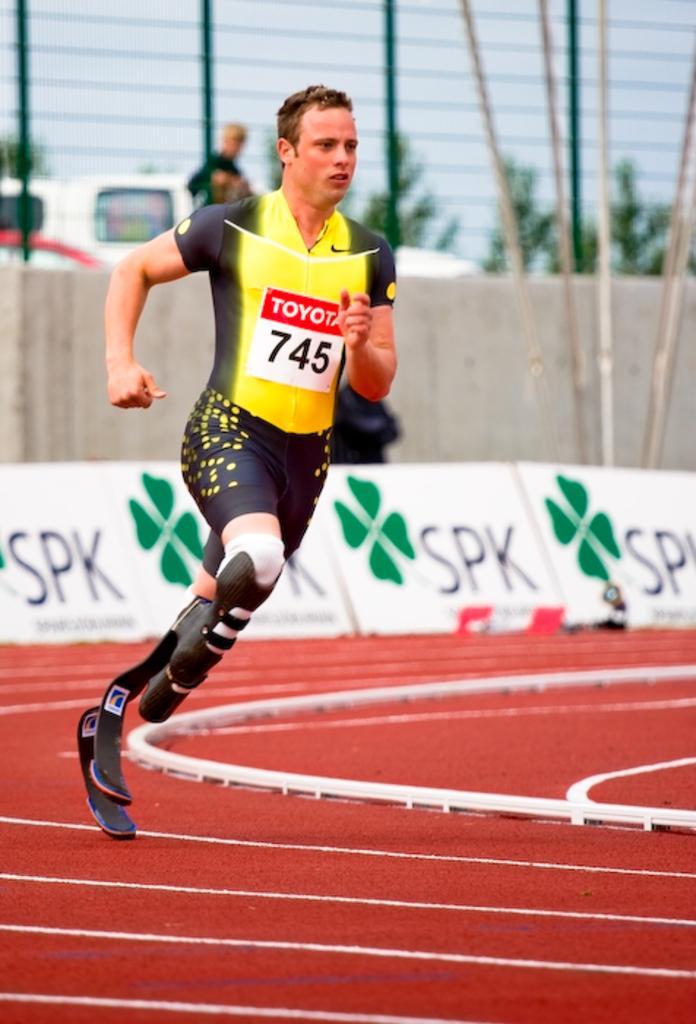How would you summarize this image in a sentence or two? This image consists of a man running. He is a handicap. At the bottom, there is a ground. In the background, there is a fencing along with the banners. 